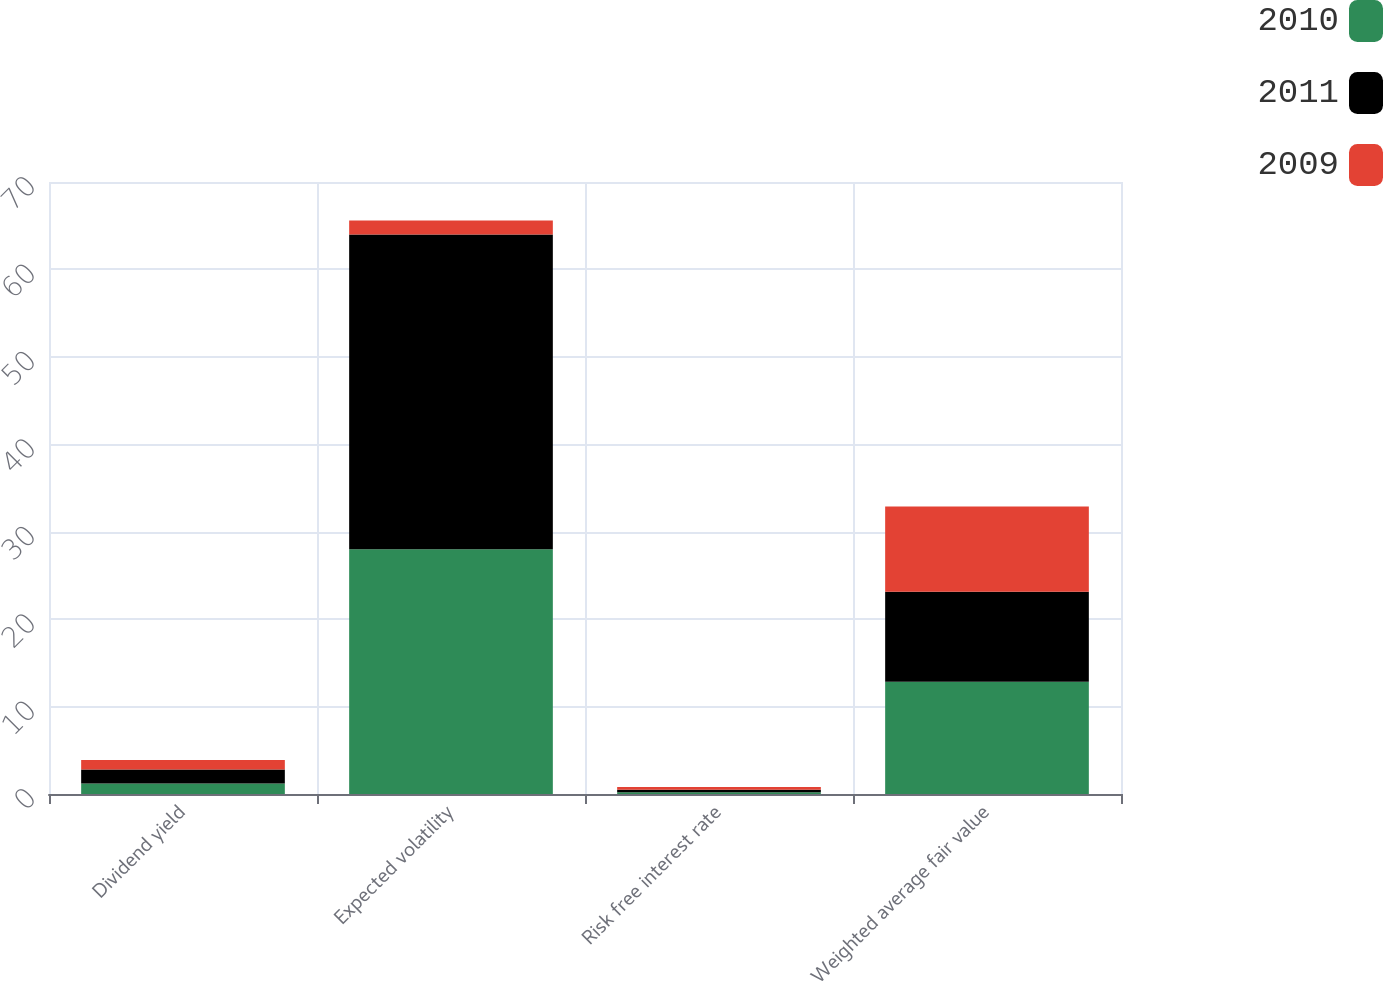Convert chart to OTSL. <chart><loc_0><loc_0><loc_500><loc_500><stacked_bar_chart><ecel><fcel>Dividend yield<fcel>Expected volatility<fcel>Risk free interest rate<fcel>Weighted average fair value<nl><fcel>2010<fcel>1.2<fcel>28<fcel>0.2<fcel>12.83<nl><fcel>2011<fcel>1.6<fcel>36<fcel>0.3<fcel>10.3<nl><fcel>2009<fcel>1.1<fcel>1.6<fcel>0.3<fcel>9.76<nl></chart> 